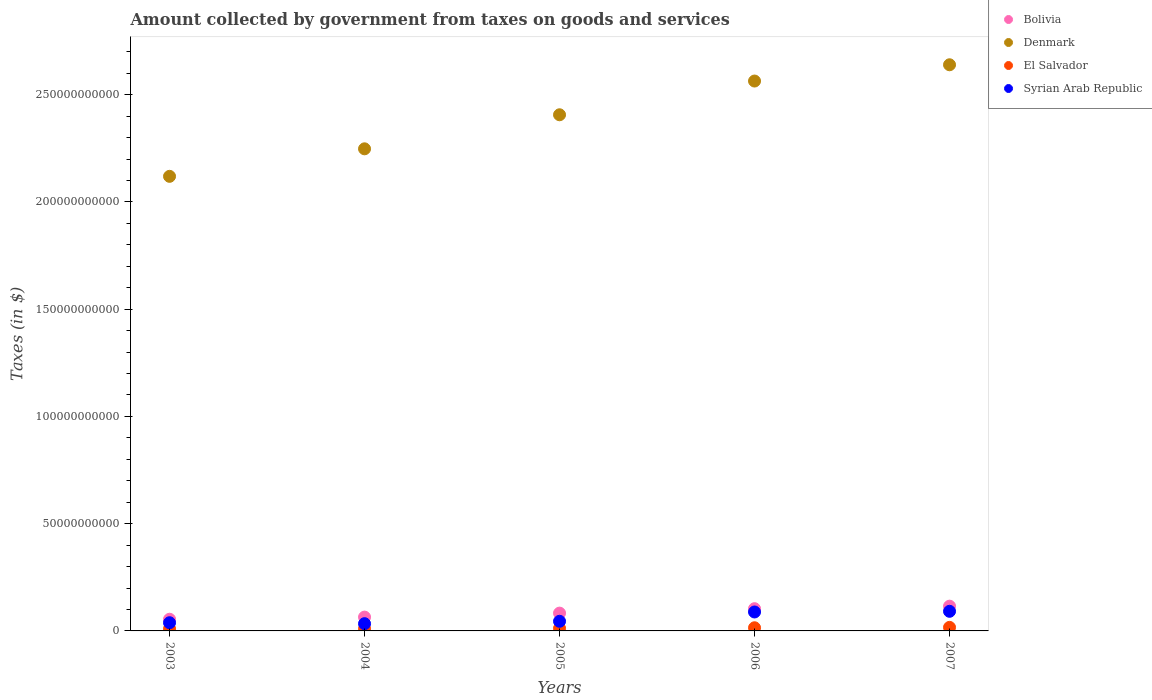How many different coloured dotlines are there?
Your answer should be compact. 4. Is the number of dotlines equal to the number of legend labels?
Offer a terse response. Yes. What is the amount collected by government from taxes on goods and services in Bolivia in 2003?
Give a very brief answer. 5.45e+09. Across all years, what is the maximum amount collected by government from taxes on goods and services in El Salvador?
Your response must be concise. 1.66e+09. Across all years, what is the minimum amount collected by government from taxes on goods and services in Bolivia?
Your answer should be very brief. 5.45e+09. In which year was the amount collected by government from taxes on goods and services in El Salvador maximum?
Your response must be concise. 2007. In which year was the amount collected by government from taxes on goods and services in Denmark minimum?
Your response must be concise. 2003. What is the total amount collected by government from taxes on goods and services in Syrian Arab Republic in the graph?
Offer a terse response. 2.97e+1. What is the difference between the amount collected by government from taxes on goods and services in Bolivia in 2003 and that in 2007?
Make the answer very short. -6.09e+09. What is the difference between the amount collected by government from taxes on goods and services in Denmark in 2006 and the amount collected by government from taxes on goods and services in El Salvador in 2007?
Your response must be concise. 2.55e+11. What is the average amount collected by government from taxes on goods and services in El Salvador per year?
Offer a very short reply. 1.27e+09. In the year 2007, what is the difference between the amount collected by government from taxes on goods and services in Bolivia and amount collected by government from taxes on goods and services in Denmark?
Provide a succinct answer. -2.52e+11. In how many years, is the amount collected by government from taxes on goods and services in Bolivia greater than 230000000000 $?
Your response must be concise. 0. What is the ratio of the amount collected by government from taxes on goods and services in Bolivia in 2004 to that in 2005?
Provide a short and direct response. 0.78. What is the difference between the highest and the second highest amount collected by government from taxes on goods and services in El Salvador?
Provide a succinct answer. 1.86e+08. What is the difference between the highest and the lowest amount collected by government from taxes on goods and services in El Salvador?
Offer a very short reply. 6.72e+08. Does the amount collected by government from taxes on goods and services in Syrian Arab Republic monotonically increase over the years?
Your answer should be very brief. No. Is the amount collected by government from taxes on goods and services in Syrian Arab Republic strictly less than the amount collected by government from taxes on goods and services in Bolivia over the years?
Your response must be concise. Yes. What is the difference between two consecutive major ticks on the Y-axis?
Provide a short and direct response. 5.00e+1. Does the graph contain grids?
Keep it short and to the point. No. How many legend labels are there?
Keep it short and to the point. 4. What is the title of the graph?
Your response must be concise. Amount collected by government from taxes on goods and services. Does "Middle income" appear as one of the legend labels in the graph?
Provide a succinct answer. No. What is the label or title of the X-axis?
Give a very brief answer. Years. What is the label or title of the Y-axis?
Provide a succinct answer. Taxes (in $). What is the Taxes (in $) in Bolivia in 2003?
Offer a very short reply. 5.45e+09. What is the Taxes (in $) of Denmark in 2003?
Give a very brief answer. 2.12e+11. What is the Taxes (in $) of El Salvador in 2003?
Your response must be concise. 9.86e+08. What is the Taxes (in $) of Syrian Arab Republic in 2003?
Offer a very short reply. 3.82e+09. What is the Taxes (in $) in Bolivia in 2004?
Ensure brevity in your answer.  6.44e+09. What is the Taxes (in $) of Denmark in 2004?
Your answer should be compact. 2.25e+11. What is the Taxes (in $) of El Salvador in 2004?
Your answer should be compact. 1.02e+09. What is the Taxes (in $) in Syrian Arab Republic in 2004?
Provide a short and direct response. 3.38e+09. What is the Taxes (in $) in Bolivia in 2005?
Your response must be concise. 8.30e+09. What is the Taxes (in $) in Denmark in 2005?
Your response must be concise. 2.41e+11. What is the Taxes (in $) in El Salvador in 2005?
Provide a succinct answer. 1.21e+09. What is the Taxes (in $) in Syrian Arab Republic in 2005?
Offer a very short reply. 4.49e+09. What is the Taxes (in $) in Bolivia in 2006?
Your response must be concise. 1.04e+1. What is the Taxes (in $) of Denmark in 2006?
Provide a short and direct response. 2.56e+11. What is the Taxes (in $) of El Salvador in 2006?
Offer a very short reply. 1.47e+09. What is the Taxes (in $) of Syrian Arab Republic in 2006?
Offer a very short reply. 8.83e+09. What is the Taxes (in $) of Bolivia in 2007?
Ensure brevity in your answer.  1.15e+1. What is the Taxes (in $) in Denmark in 2007?
Your answer should be very brief. 2.64e+11. What is the Taxes (in $) of El Salvador in 2007?
Provide a succinct answer. 1.66e+09. What is the Taxes (in $) in Syrian Arab Republic in 2007?
Provide a succinct answer. 9.14e+09. Across all years, what is the maximum Taxes (in $) of Bolivia?
Your response must be concise. 1.15e+1. Across all years, what is the maximum Taxes (in $) in Denmark?
Keep it short and to the point. 2.64e+11. Across all years, what is the maximum Taxes (in $) of El Salvador?
Your answer should be very brief. 1.66e+09. Across all years, what is the maximum Taxes (in $) of Syrian Arab Republic?
Give a very brief answer. 9.14e+09. Across all years, what is the minimum Taxes (in $) of Bolivia?
Ensure brevity in your answer.  5.45e+09. Across all years, what is the minimum Taxes (in $) in Denmark?
Keep it short and to the point. 2.12e+11. Across all years, what is the minimum Taxes (in $) of El Salvador?
Your response must be concise. 9.86e+08. Across all years, what is the minimum Taxes (in $) of Syrian Arab Republic?
Offer a terse response. 3.38e+09. What is the total Taxes (in $) of Bolivia in the graph?
Ensure brevity in your answer.  4.21e+1. What is the total Taxes (in $) in Denmark in the graph?
Give a very brief answer. 1.20e+12. What is the total Taxes (in $) in El Salvador in the graph?
Ensure brevity in your answer.  6.34e+09. What is the total Taxes (in $) in Syrian Arab Republic in the graph?
Ensure brevity in your answer.  2.97e+1. What is the difference between the Taxes (in $) in Bolivia in 2003 and that in 2004?
Offer a terse response. -9.93e+08. What is the difference between the Taxes (in $) of Denmark in 2003 and that in 2004?
Ensure brevity in your answer.  -1.28e+1. What is the difference between the Taxes (in $) in El Salvador in 2003 and that in 2004?
Provide a short and direct response. -3.62e+07. What is the difference between the Taxes (in $) of Syrian Arab Republic in 2003 and that in 2004?
Keep it short and to the point. 4.42e+08. What is the difference between the Taxes (in $) in Bolivia in 2003 and that in 2005?
Your response must be concise. -2.85e+09. What is the difference between the Taxes (in $) of Denmark in 2003 and that in 2005?
Offer a terse response. -2.87e+1. What is the difference between the Taxes (in $) of El Salvador in 2003 and that in 2005?
Provide a short and direct response. -2.20e+08. What is the difference between the Taxes (in $) in Syrian Arab Republic in 2003 and that in 2005?
Provide a succinct answer. -6.73e+08. What is the difference between the Taxes (in $) in Bolivia in 2003 and that in 2006?
Make the answer very short. -4.92e+09. What is the difference between the Taxes (in $) of Denmark in 2003 and that in 2006?
Ensure brevity in your answer.  -4.44e+1. What is the difference between the Taxes (in $) in El Salvador in 2003 and that in 2006?
Offer a terse response. -4.86e+08. What is the difference between the Taxes (in $) of Syrian Arab Republic in 2003 and that in 2006?
Your response must be concise. -5.01e+09. What is the difference between the Taxes (in $) of Bolivia in 2003 and that in 2007?
Make the answer very short. -6.09e+09. What is the difference between the Taxes (in $) of Denmark in 2003 and that in 2007?
Keep it short and to the point. -5.20e+1. What is the difference between the Taxes (in $) of El Salvador in 2003 and that in 2007?
Provide a short and direct response. -6.72e+08. What is the difference between the Taxes (in $) in Syrian Arab Republic in 2003 and that in 2007?
Offer a terse response. -5.32e+09. What is the difference between the Taxes (in $) of Bolivia in 2004 and that in 2005?
Your response must be concise. -1.86e+09. What is the difference between the Taxes (in $) in Denmark in 2004 and that in 2005?
Keep it short and to the point. -1.59e+1. What is the difference between the Taxes (in $) of El Salvador in 2004 and that in 2005?
Provide a short and direct response. -1.83e+08. What is the difference between the Taxes (in $) in Syrian Arab Republic in 2004 and that in 2005?
Make the answer very short. -1.12e+09. What is the difference between the Taxes (in $) in Bolivia in 2004 and that in 2006?
Provide a short and direct response. -3.92e+09. What is the difference between the Taxes (in $) in Denmark in 2004 and that in 2006?
Provide a succinct answer. -3.16e+1. What is the difference between the Taxes (in $) in El Salvador in 2004 and that in 2006?
Your answer should be very brief. -4.50e+08. What is the difference between the Taxes (in $) in Syrian Arab Republic in 2004 and that in 2006?
Give a very brief answer. -5.45e+09. What is the difference between the Taxes (in $) in Bolivia in 2004 and that in 2007?
Your answer should be very brief. -5.10e+09. What is the difference between the Taxes (in $) in Denmark in 2004 and that in 2007?
Your response must be concise. -3.92e+1. What is the difference between the Taxes (in $) of El Salvador in 2004 and that in 2007?
Your answer should be compact. -6.36e+08. What is the difference between the Taxes (in $) in Syrian Arab Republic in 2004 and that in 2007?
Your answer should be compact. -5.77e+09. What is the difference between the Taxes (in $) of Bolivia in 2005 and that in 2006?
Keep it short and to the point. -2.06e+09. What is the difference between the Taxes (in $) of Denmark in 2005 and that in 2006?
Your answer should be very brief. -1.57e+1. What is the difference between the Taxes (in $) in El Salvador in 2005 and that in 2006?
Your answer should be very brief. -2.67e+08. What is the difference between the Taxes (in $) in Syrian Arab Republic in 2005 and that in 2006?
Your answer should be compact. -4.34e+09. What is the difference between the Taxes (in $) of Bolivia in 2005 and that in 2007?
Provide a short and direct response. -3.24e+09. What is the difference between the Taxes (in $) in Denmark in 2005 and that in 2007?
Your answer should be compact. -2.33e+1. What is the difference between the Taxes (in $) of El Salvador in 2005 and that in 2007?
Make the answer very short. -4.52e+08. What is the difference between the Taxes (in $) in Syrian Arab Republic in 2005 and that in 2007?
Your answer should be compact. -4.65e+09. What is the difference between the Taxes (in $) in Bolivia in 2006 and that in 2007?
Your answer should be compact. -1.18e+09. What is the difference between the Taxes (in $) of Denmark in 2006 and that in 2007?
Make the answer very short. -7.58e+09. What is the difference between the Taxes (in $) in El Salvador in 2006 and that in 2007?
Keep it short and to the point. -1.86e+08. What is the difference between the Taxes (in $) in Syrian Arab Republic in 2006 and that in 2007?
Offer a very short reply. -3.13e+08. What is the difference between the Taxes (in $) in Bolivia in 2003 and the Taxes (in $) in Denmark in 2004?
Keep it short and to the point. -2.19e+11. What is the difference between the Taxes (in $) of Bolivia in 2003 and the Taxes (in $) of El Salvador in 2004?
Make the answer very short. 4.42e+09. What is the difference between the Taxes (in $) in Bolivia in 2003 and the Taxes (in $) in Syrian Arab Republic in 2004?
Make the answer very short. 2.07e+09. What is the difference between the Taxes (in $) in Denmark in 2003 and the Taxes (in $) in El Salvador in 2004?
Your answer should be very brief. 2.11e+11. What is the difference between the Taxes (in $) of Denmark in 2003 and the Taxes (in $) of Syrian Arab Republic in 2004?
Your answer should be compact. 2.09e+11. What is the difference between the Taxes (in $) of El Salvador in 2003 and the Taxes (in $) of Syrian Arab Republic in 2004?
Your answer should be compact. -2.39e+09. What is the difference between the Taxes (in $) in Bolivia in 2003 and the Taxes (in $) in Denmark in 2005?
Provide a succinct answer. -2.35e+11. What is the difference between the Taxes (in $) in Bolivia in 2003 and the Taxes (in $) in El Salvador in 2005?
Provide a short and direct response. 4.24e+09. What is the difference between the Taxes (in $) in Bolivia in 2003 and the Taxes (in $) in Syrian Arab Republic in 2005?
Ensure brevity in your answer.  9.53e+08. What is the difference between the Taxes (in $) in Denmark in 2003 and the Taxes (in $) in El Salvador in 2005?
Your answer should be compact. 2.11e+11. What is the difference between the Taxes (in $) of Denmark in 2003 and the Taxes (in $) of Syrian Arab Republic in 2005?
Your answer should be very brief. 2.07e+11. What is the difference between the Taxes (in $) in El Salvador in 2003 and the Taxes (in $) in Syrian Arab Republic in 2005?
Your response must be concise. -3.51e+09. What is the difference between the Taxes (in $) in Bolivia in 2003 and the Taxes (in $) in Denmark in 2006?
Provide a short and direct response. -2.51e+11. What is the difference between the Taxes (in $) of Bolivia in 2003 and the Taxes (in $) of El Salvador in 2006?
Provide a succinct answer. 3.97e+09. What is the difference between the Taxes (in $) of Bolivia in 2003 and the Taxes (in $) of Syrian Arab Republic in 2006?
Provide a succinct answer. -3.39e+09. What is the difference between the Taxes (in $) in Denmark in 2003 and the Taxes (in $) in El Salvador in 2006?
Make the answer very short. 2.10e+11. What is the difference between the Taxes (in $) of Denmark in 2003 and the Taxes (in $) of Syrian Arab Republic in 2006?
Ensure brevity in your answer.  2.03e+11. What is the difference between the Taxes (in $) of El Salvador in 2003 and the Taxes (in $) of Syrian Arab Republic in 2006?
Your response must be concise. -7.85e+09. What is the difference between the Taxes (in $) of Bolivia in 2003 and the Taxes (in $) of Denmark in 2007?
Your response must be concise. -2.59e+11. What is the difference between the Taxes (in $) in Bolivia in 2003 and the Taxes (in $) in El Salvador in 2007?
Ensure brevity in your answer.  3.79e+09. What is the difference between the Taxes (in $) of Bolivia in 2003 and the Taxes (in $) of Syrian Arab Republic in 2007?
Keep it short and to the point. -3.70e+09. What is the difference between the Taxes (in $) of Denmark in 2003 and the Taxes (in $) of El Salvador in 2007?
Make the answer very short. 2.10e+11. What is the difference between the Taxes (in $) in Denmark in 2003 and the Taxes (in $) in Syrian Arab Republic in 2007?
Provide a short and direct response. 2.03e+11. What is the difference between the Taxes (in $) of El Salvador in 2003 and the Taxes (in $) of Syrian Arab Republic in 2007?
Offer a very short reply. -8.16e+09. What is the difference between the Taxes (in $) in Bolivia in 2004 and the Taxes (in $) in Denmark in 2005?
Provide a short and direct response. -2.34e+11. What is the difference between the Taxes (in $) in Bolivia in 2004 and the Taxes (in $) in El Salvador in 2005?
Offer a terse response. 5.23e+09. What is the difference between the Taxes (in $) of Bolivia in 2004 and the Taxes (in $) of Syrian Arab Republic in 2005?
Keep it short and to the point. 1.95e+09. What is the difference between the Taxes (in $) in Denmark in 2004 and the Taxes (in $) in El Salvador in 2005?
Make the answer very short. 2.24e+11. What is the difference between the Taxes (in $) of Denmark in 2004 and the Taxes (in $) of Syrian Arab Republic in 2005?
Your response must be concise. 2.20e+11. What is the difference between the Taxes (in $) of El Salvador in 2004 and the Taxes (in $) of Syrian Arab Republic in 2005?
Offer a terse response. -3.47e+09. What is the difference between the Taxes (in $) in Bolivia in 2004 and the Taxes (in $) in Denmark in 2006?
Your answer should be compact. -2.50e+11. What is the difference between the Taxes (in $) of Bolivia in 2004 and the Taxes (in $) of El Salvador in 2006?
Provide a short and direct response. 4.97e+09. What is the difference between the Taxes (in $) of Bolivia in 2004 and the Taxes (in $) of Syrian Arab Republic in 2006?
Offer a terse response. -2.39e+09. What is the difference between the Taxes (in $) in Denmark in 2004 and the Taxes (in $) in El Salvador in 2006?
Give a very brief answer. 2.23e+11. What is the difference between the Taxes (in $) in Denmark in 2004 and the Taxes (in $) in Syrian Arab Republic in 2006?
Provide a succinct answer. 2.16e+11. What is the difference between the Taxes (in $) of El Salvador in 2004 and the Taxes (in $) of Syrian Arab Republic in 2006?
Give a very brief answer. -7.81e+09. What is the difference between the Taxes (in $) of Bolivia in 2004 and the Taxes (in $) of Denmark in 2007?
Ensure brevity in your answer.  -2.58e+11. What is the difference between the Taxes (in $) of Bolivia in 2004 and the Taxes (in $) of El Salvador in 2007?
Keep it short and to the point. 4.78e+09. What is the difference between the Taxes (in $) in Bolivia in 2004 and the Taxes (in $) in Syrian Arab Republic in 2007?
Offer a very short reply. -2.71e+09. What is the difference between the Taxes (in $) in Denmark in 2004 and the Taxes (in $) in El Salvador in 2007?
Give a very brief answer. 2.23e+11. What is the difference between the Taxes (in $) of Denmark in 2004 and the Taxes (in $) of Syrian Arab Republic in 2007?
Offer a terse response. 2.16e+11. What is the difference between the Taxes (in $) in El Salvador in 2004 and the Taxes (in $) in Syrian Arab Republic in 2007?
Ensure brevity in your answer.  -8.12e+09. What is the difference between the Taxes (in $) in Bolivia in 2005 and the Taxes (in $) in Denmark in 2006?
Make the answer very short. -2.48e+11. What is the difference between the Taxes (in $) of Bolivia in 2005 and the Taxes (in $) of El Salvador in 2006?
Your answer should be very brief. 6.83e+09. What is the difference between the Taxes (in $) in Bolivia in 2005 and the Taxes (in $) in Syrian Arab Republic in 2006?
Offer a terse response. -5.33e+08. What is the difference between the Taxes (in $) of Denmark in 2005 and the Taxes (in $) of El Salvador in 2006?
Make the answer very short. 2.39e+11. What is the difference between the Taxes (in $) of Denmark in 2005 and the Taxes (in $) of Syrian Arab Republic in 2006?
Keep it short and to the point. 2.32e+11. What is the difference between the Taxes (in $) of El Salvador in 2005 and the Taxes (in $) of Syrian Arab Republic in 2006?
Provide a succinct answer. -7.63e+09. What is the difference between the Taxes (in $) of Bolivia in 2005 and the Taxes (in $) of Denmark in 2007?
Provide a short and direct response. -2.56e+11. What is the difference between the Taxes (in $) of Bolivia in 2005 and the Taxes (in $) of El Salvador in 2007?
Make the answer very short. 6.64e+09. What is the difference between the Taxes (in $) in Bolivia in 2005 and the Taxes (in $) in Syrian Arab Republic in 2007?
Offer a terse response. -8.46e+08. What is the difference between the Taxes (in $) of Denmark in 2005 and the Taxes (in $) of El Salvador in 2007?
Your answer should be compact. 2.39e+11. What is the difference between the Taxes (in $) in Denmark in 2005 and the Taxes (in $) in Syrian Arab Republic in 2007?
Offer a very short reply. 2.31e+11. What is the difference between the Taxes (in $) of El Salvador in 2005 and the Taxes (in $) of Syrian Arab Republic in 2007?
Provide a succinct answer. -7.94e+09. What is the difference between the Taxes (in $) in Bolivia in 2006 and the Taxes (in $) in Denmark in 2007?
Your answer should be very brief. -2.54e+11. What is the difference between the Taxes (in $) in Bolivia in 2006 and the Taxes (in $) in El Salvador in 2007?
Your response must be concise. 8.70e+09. What is the difference between the Taxes (in $) in Bolivia in 2006 and the Taxes (in $) in Syrian Arab Republic in 2007?
Offer a terse response. 1.22e+09. What is the difference between the Taxes (in $) in Denmark in 2006 and the Taxes (in $) in El Salvador in 2007?
Provide a short and direct response. 2.55e+11. What is the difference between the Taxes (in $) in Denmark in 2006 and the Taxes (in $) in Syrian Arab Republic in 2007?
Your answer should be very brief. 2.47e+11. What is the difference between the Taxes (in $) in El Salvador in 2006 and the Taxes (in $) in Syrian Arab Republic in 2007?
Provide a succinct answer. -7.67e+09. What is the average Taxes (in $) of Bolivia per year?
Give a very brief answer. 8.42e+09. What is the average Taxes (in $) of Denmark per year?
Your answer should be very brief. 2.40e+11. What is the average Taxes (in $) of El Salvador per year?
Offer a very short reply. 1.27e+09. What is the average Taxes (in $) in Syrian Arab Republic per year?
Provide a succinct answer. 5.93e+09. In the year 2003, what is the difference between the Taxes (in $) in Bolivia and Taxes (in $) in Denmark?
Your answer should be very brief. -2.06e+11. In the year 2003, what is the difference between the Taxes (in $) of Bolivia and Taxes (in $) of El Salvador?
Make the answer very short. 4.46e+09. In the year 2003, what is the difference between the Taxes (in $) in Bolivia and Taxes (in $) in Syrian Arab Republic?
Provide a short and direct response. 1.63e+09. In the year 2003, what is the difference between the Taxes (in $) in Denmark and Taxes (in $) in El Salvador?
Provide a short and direct response. 2.11e+11. In the year 2003, what is the difference between the Taxes (in $) of Denmark and Taxes (in $) of Syrian Arab Republic?
Provide a short and direct response. 2.08e+11. In the year 2003, what is the difference between the Taxes (in $) of El Salvador and Taxes (in $) of Syrian Arab Republic?
Offer a terse response. -2.84e+09. In the year 2004, what is the difference between the Taxes (in $) of Bolivia and Taxes (in $) of Denmark?
Keep it short and to the point. -2.18e+11. In the year 2004, what is the difference between the Taxes (in $) in Bolivia and Taxes (in $) in El Salvador?
Ensure brevity in your answer.  5.42e+09. In the year 2004, what is the difference between the Taxes (in $) in Bolivia and Taxes (in $) in Syrian Arab Republic?
Provide a succinct answer. 3.06e+09. In the year 2004, what is the difference between the Taxes (in $) in Denmark and Taxes (in $) in El Salvador?
Offer a terse response. 2.24e+11. In the year 2004, what is the difference between the Taxes (in $) in Denmark and Taxes (in $) in Syrian Arab Republic?
Make the answer very short. 2.21e+11. In the year 2004, what is the difference between the Taxes (in $) in El Salvador and Taxes (in $) in Syrian Arab Republic?
Keep it short and to the point. -2.36e+09. In the year 2005, what is the difference between the Taxes (in $) of Bolivia and Taxes (in $) of Denmark?
Keep it short and to the point. -2.32e+11. In the year 2005, what is the difference between the Taxes (in $) of Bolivia and Taxes (in $) of El Salvador?
Provide a short and direct response. 7.09e+09. In the year 2005, what is the difference between the Taxes (in $) in Bolivia and Taxes (in $) in Syrian Arab Republic?
Make the answer very short. 3.81e+09. In the year 2005, what is the difference between the Taxes (in $) of Denmark and Taxes (in $) of El Salvador?
Provide a succinct answer. 2.39e+11. In the year 2005, what is the difference between the Taxes (in $) of Denmark and Taxes (in $) of Syrian Arab Republic?
Give a very brief answer. 2.36e+11. In the year 2005, what is the difference between the Taxes (in $) in El Salvador and Taxes (in $) in Syrian Arab Republic?
Your answer should be very brief. -3.29e+09. In the year 2006, what is the difference between the Taxes (in $) of Bolivia and Taxes (in $) of Denmark?
Your answer should be very brief. -2.46e+11. In the year 2006, what is the difference between the Taxes (in $) in Bolivia and Taxes (in $) in El Salvador?
Your response must be concise. 8.89e+09. In the year 2006, what is the difference between the Taxes (in $) of Bolivia and Taxes (in $) of Syrian Arab Republic?
Your response must be concise. 1.53e+09. In the year 2006, what is the difference between the Taxes (in $) of Denmark and Taxes (in $) of El Salvador?
Your response must be concise. 2.55e+11. In the year 2006, what is the difference between the Taxes (in $) of Denmark and Taxes (in $) of Syrian Arab Republic?
Offer a terse response. 2.48e+11. In the year 2006, what is the difference between the Taxes (in $) in El Salvador and Taxes (in $) in Syrian Arab Republic?
Give a very brief answer. -7.36e+09. In the year 2007, what is the difference between the Taxes (in $) in Bolivia and Taxes (in $) in Denmark?
Provide a succinct answer. -2.52e+11. In the year 2007, what is the difference between the Taxes (in $) in Bolivia and Taxes (in $) in El Salvador?
Your answer should be compact. 9.88e+09. In the year 2007, what is the difference between the Taxes (in $) in Bolivia and Taxes (in $) in Syrian Arab Republic?
Keep it short and to the point. 2.39e+09. In the year 2007, what is the difference between the Taxes (in $) of Denmark and Taxes (in $) of El Salvador?
Your answer should be very brief. 2.62e+11. In the year 2007, what is the difference between the Taxes (in $) of Denmark and Taxes (in $) of Syrian Arab Republic?
Offer a very short reply. 2.55e+11. In the year 2007, what is the difference between the Taxes (in $) of El Salvador and Taxes (in $) of Syrian Arab Republic?
Your answer should be very brief. -7.49e+09. What is the ratio of the Taxes (in $) of Bolivia in 2003 to that in 2004?
Give a very brief answer. 0.85. What is the ratio of the Taxes (in $) in Denmark in 2003 to that in 2004?
Ensure brevity in your answer.  0.94. What is the ratio of the Taxes (in $) of El Salvador in 2003 to that in 2004?
Your answer should be very brief. 0.96. What is the ratio of the Taxes (in $) of Syrian Arab Republic in 2003 to that in 2004?
Make the answer very short. 1.13. What is the ratio of the Taxes (in $) in Bolivia in 2003 to that in 2005?
Ensure brevity in your answer.  0.66. What is the ratio of the Taxes (in $) in Denmark in 2003 to that in 2005?
Keep it short and to the point. 0.88. What is the ratio of the Taxes (in $) of El Salvador in 2003 to that in 2005?
Keep it short and to the point. 0.82. What is the ratio of the Taxes (in $) of Syrian Arab Republic in 2003 to that in 2005?
Provide a succinct answer. 0.85. What is the ratio of the Taxes (in $) in Bolivia in 2003 to that in 2006?
Offer a terse response. 0.53. What is the ratio of the Taxes (in $) of Denmark in 2003 to that in 2006?
Offer a very short reply. 0.83. What is the ratio of the Taxes (in $) of El Salvador in 2003 to that in 2006?
Give a very brief answer. 0.67. What is the ratio of the Taxes (in $) of Syrian Arab Republic in 2003 to that in 2006?
Offer a very short reply. 0.43. What is the ratio of the Taxes (in $) of Bolivia in 2003 to that in 2007?
Provide a succinct answer. 0.47. What is the ratio of the Taxes (in $) of Denmark in 2003 to that in 2007?
Ensure brevity in your answer.  0.8. What is the ratio of the Taxes (in $) of El Salvador in 2003 to that in 2007?
Your response must be concise. 0.59. What is the ratio of the Taxes (in $) of Syrian Arab Republic in 2003 to that in 2007?
Offer a terse response. 0.42. What is the ratio of the Taxes (in $) in Bolivia in 2004 to that in 2005?
Make the answer very short. 0.78. What is the ratio of the Taxes (in $) of Denmark in 2004 to that in 2005?
Provide a short and direct response. 0.93. What is the ratio of the Taxes (in $) in El Salvador in 2004 to that in 2005?
Provide a short and direct response. 0.85. What is the ratio of the Taxes (in $) in Syrian Arab Republic in 2004 to that in 2005?
Keep it short and to the point. 0.75. What is the ratio of the Taxes (in $) of Bolivia in 2004 to that in 2006?
Provide a succinct answer. 0.62. What is the ratio of the Taxes (in $) in Denmark in 2004 to that in 2006?
Your response must be concise. 0.88. What is the ratio of the Taxes (in $) of El Salvador in 2004 to that in 2006?
Your answer should be very brief. 0.69. What is the ratio of the Taxes (in $) of Syrian Arab Republic in 2004 to that in 2006?
Provide a short and direct response. 0.38. What is the ratio of the Taxes (in $) in Bolivia in 2004 to that in 2007?
Give a very brief answer. 0.56. What is the ratio of the Taxes (in $) in Denmark in 2004 to that in 2007?
Your answer should be very brief. 0.85. What is the ratio of the Taxes (in $) in El Salvador in 2004 to that in 2007?
Give a very brief answer. 0.62. What is the ratio of the Taxes (in $) of Syrian Arab Republic in 2004 to that in 2007?
Offer a very short reply. 0.37. What is the ratio of the Taxes (in $) of Bolivia in 2005 to that in 2006?
Provide a short and direct response. 0.8. What is the ratio of the Taxes (in $) of Denmark in 2005 to that in 2006?
Offer a terse response. 0.94. What is the ratio of the Taxes (in $) of El Salvador in 2005 to that in 2006?
Your response must be concise. 0.82. What is the ratio of the Taxes (in $) of Syrian Arab Republic in 2005 to that in 2006?
Provide a short and direct response. 0.51. What is the ratio of the Taxes (in $) of Bolivia in 2005 to that in 2007?
Offer a terse response. 0.72. What is the ratio of the Taxes (in $) of Denmark in 2005 to that in 2007?
Offer a very short reply. 0.91. What is the ratio of the Taxes (in $) in El Salvador in 2005 to that in 2007?
Your response must be concise. 0.73. What is the ratio of the Taxes (in $) in Syrian Arab Republic in 2005 to that in 2007?
Give a very brief answer. 0.49. What is the ratio of the Taxes (in $) in Bolivia in 2006 to that in 2007?
Your response must be concise. 0.9. What is the ratio of the Taxes (in $) of Denmark in 2006 to that in 2007?
Make the answer very short. 0.97. What is the ratio of the Taxes (in $) of El Salvador in 2006 to that in 2007?
Ensure brevity in your answer.  0.89. What is the ratio of the Taxes (in $) in Syrian Arab Republic in 2006 to that in 2007?
Provide a short and direct response. 0.97. What is the difference between the highest and the second highest Taxes (in $) in Bolivia?
Provide a succinct answer. 1.18e+09. What is the difference between the highest and the second highest Taxes (in $) in Denmark?
Offer a very short reply. 7.58e+09. What is the difference between the highest and the second highest Taxes (in $) of El Salvador?
Provide a short and direct response. 1.86e+08. What is the difference between the highest and the second highest Taxes (in $) in Syrian Arab Republic?
Your answer should be very brief. 3.13e+08. What is the difference between the highest and the lowest Taxes (in $) in Bolivia?
Keep it short and to the point. 6.09e+09. What is the difference between the highest and the lowest Taxes (in $) of Denmark?
Your answer should be compact. 5.20e+1. What is the difference between the highest and the lowest Taxes (in $) in El Salvador?
Offer a very short reply. 6.72e+08. What is the difference between the highest and the lowest Taxes (in $) of Syrian Arab Republic?
Your response must be concise. 5.77e+09. 